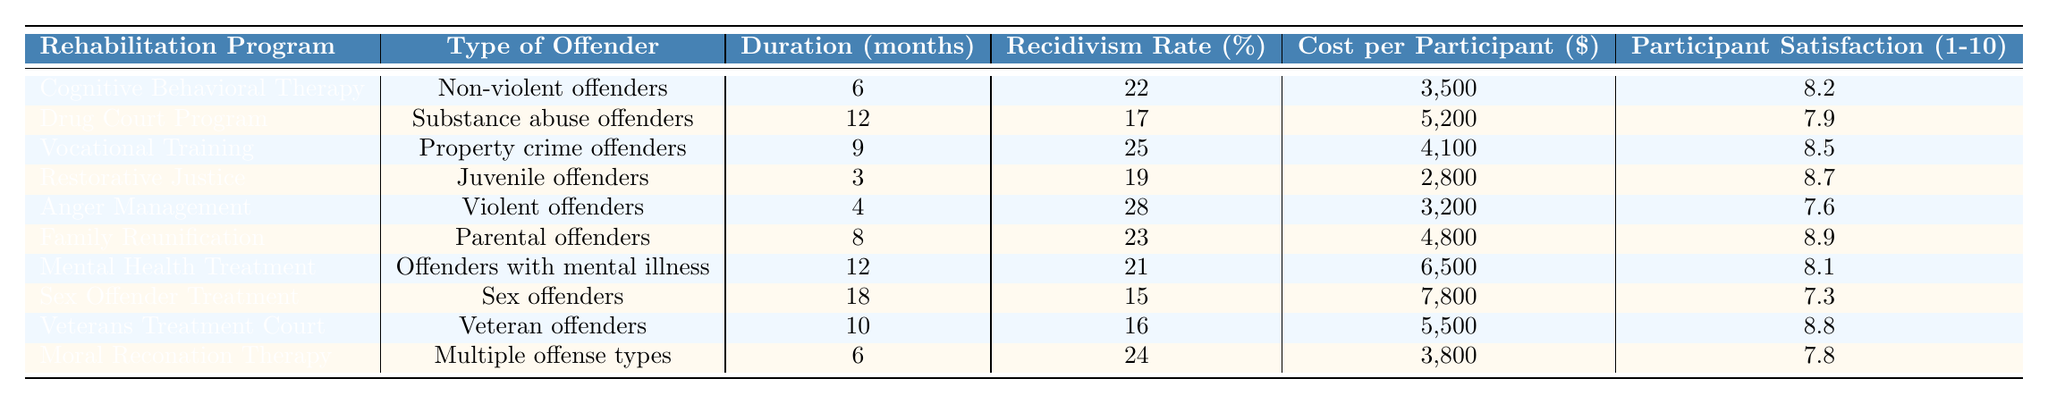What is the recidivism rate for the Drug Court Program? The recidivism rate listed under the Drug Court Program is 17%.
Answer: 17% Which rehabilitation program has the highest participant satisfaction? The Family Reunification program has the highest participant satisfaction score of 8.9.
Answer: 8.9 What is the average duration of the rehabilitation programs listed? The durations are 6, 12, 9, 3, 4, 8, 12, 18, 10, and 6 months, which totals 88 months. Dividing by 10 participants gives an average of 8.8 months.
Answer: 8.8 Is the recidivism rate for Sex Offender Treatment lower than that for Vocational Training? The recidivism rate for Sex Offender Treatment is 15%, while for Vocational Training it is 25%. Therefore, it is lower.
Answer: Yes Which program is the most expensive on a cost per participant basis? The Sex Offender Treatment program is the most expensive at $7,800 per participant.
Answer: $7,800 What is the difference in recidivism rate between the Anger Management program and the Drug Court Program? The recidivism rate for Anger Management is 28% and for Drug Court Program is 17%. The difference is 28% - 17% = 11%.
Answer: 11% Do more months of program duration correlate with higher recidivism rates? Comparing programs, longer durations like the Sex Offender Treatment (18 months, 15% recidivism) and shorter ones like Restorative Justice (3 months, 19% recidivism) do not show a clear correlation; hence, the statement is false.
Answer: No What are the types of offenders that have a recidivism rate above 20%? The types of offenders with a recidivism rate above 20% include Non-violent offenders (22%), Property crime offenders (25%), Family Reunification (23%), Anger Management (28%), and Moral Reconation Therapy (24%).
Answer: Non-violent, Property crime, Family Reunification, Violent, Multiple offense types What is the average cost per participant across all listed programs? The costs are 3500, 5200, 4100, 2800, 3200, 4800, 6500, 7800, 5500, and 3800 totaling $39,400. Dividing by 10 gives an average of $3,940.
Answer: $3,940 Which type of offender has the longest rehabilitation program duration, and what is it? The type of offender with the longest duration is Sex offenders with a program duration of 18 months.
Answer: Sex offenders, 18 months 